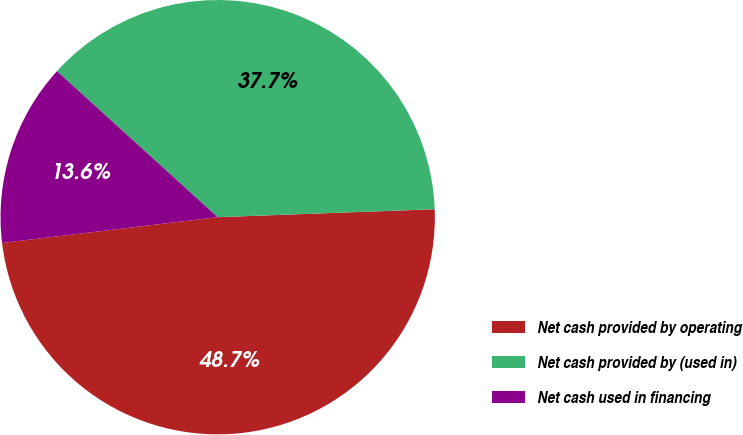<chart> <loc_0><loc_0><loc_500><loc_500><pie_chart><fcel>Net cash provided by operating<fcel>Net cash provided by (used in)<fcel>Net cash used in financing<nl><fcel>48.69%<fcel>37.68%<fcel>13.63%<nl></chart> 